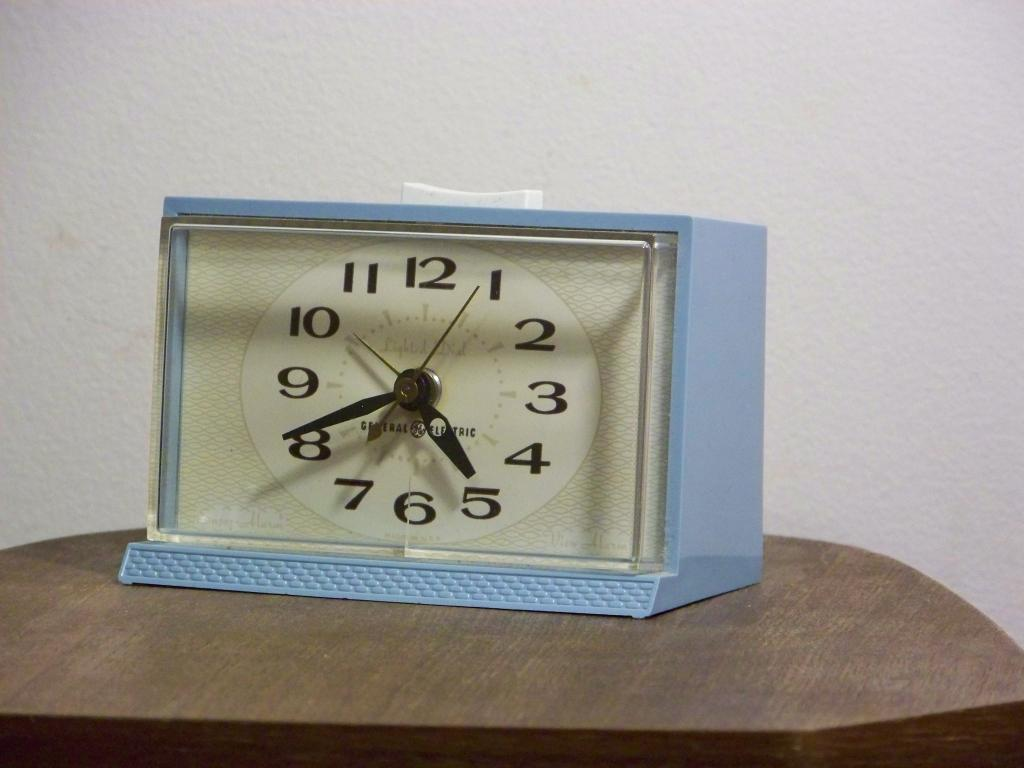Provide a one-sentence caption for the provided image. A blue analog table clock with a glass front on a wood table. 